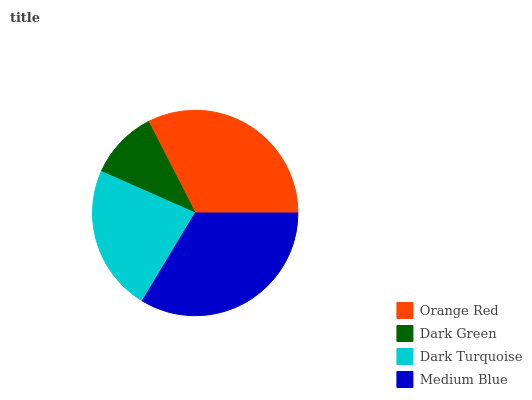Is Dark Green the minimum?
Answer yes or no. Yes. Is Medium Blue the maximum?
Answer yes or no. Yes. Is Dark Turquoise the minimum?
Answer yes or no. No. Is Dark Turquoise the maximum?
Answer yes or no. No. Is Dark Turquoise greater than Dark Green?
Answer yes or no. Yes. Is Dark Green less than Dark Turquoise?
Answer yes or no. Yes. Is Dark Green greater than Dark Turquoise?
Answer yes or no. No. Is Dark Turquoise less than Dark Green?
Answer yes or no. No. Is Orange Red the high median?
Answer yes or no. Yes. Is Dark Turquoise the low median?
Answer yes or no. Yes. Is Dark Green the high median?
Answer yes or no. No. Is Orange Red the low median?
Answer yes or no. No. 